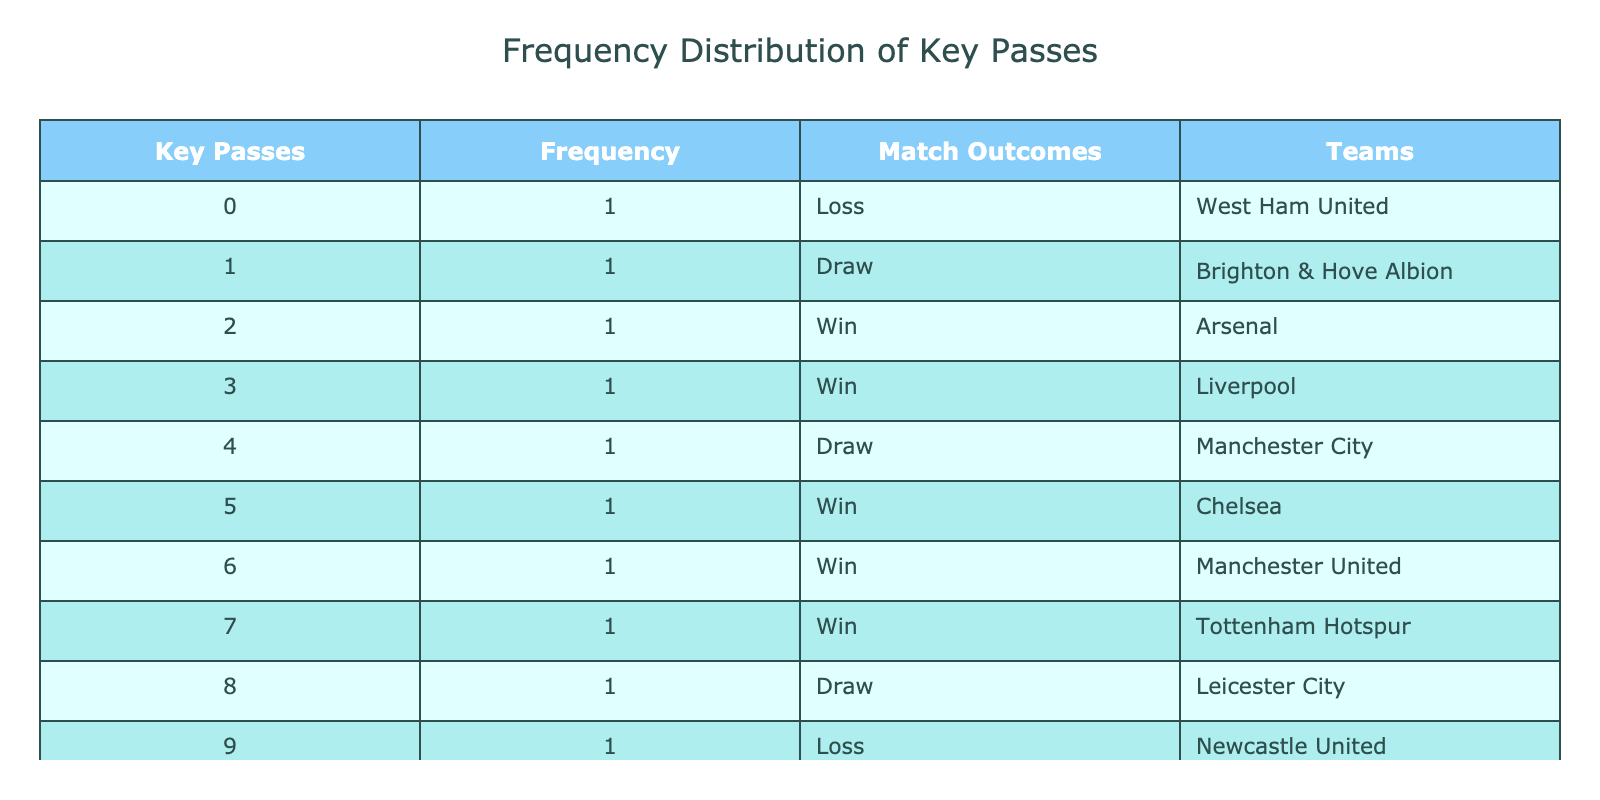What is the total number of matches that resulted in a win? To find the total number of wins, we need to count the matches in the "Match Outcomes" column that are labeled as "Win." There are five outcomes marked as "Win" (Arsenal, Liverpool, Chelsea, Manchester United, Tottenham Hotspur, and Everton).
Answer: 6 Which team had the highest number of key passes in a single match? To identify the team with the highest number of key passes, we look at the "Key Passes" column and find the maximum value, which is 10. The team corresponding to this value is Everton.
Answer: Everton Did any matches with 0 key passes result in a win? Looking at the row with 0 key passes, the match outcome is "Loss" for West Ham United. Therefore, no matches with 0 key passes resulted in a win.
Answer: No How many teams drew matches that had exactly 1 key pass? To answer this, we check the "Key Passes" column for the value 1 and find that it corresponds to one match, which ended in a "Draw," for Brighton & Hove Albion. Thus, there is only one team that drew matches with exactly 1 key pass.
Answer: 1 What is the difference in the number of matches won compared to those that ended in a draw? Using the counts of outcomes, there are 6 matches that resulted in a win (total of 6) and 4 matches that ended in a draw (Brighton & Hove Albion, Manchester City, Leicester City). The difference is calculated as follows: 6 (wins) - 3 (draws) = 3.
Answer: 3 Are there any teams that lost matches while making more than 3 key passes? Checking the "Match Outcomes" for teams with greater than 3 key passes shows that Newcastle United, who lost, only made 9 key passes. Therefore, there is indeed a team that lost while achieving 9 key passes.
Answer: Yes What is the frequency of matches that resulted in a loss? To find the frequency of losses, we should count how many rows indicate a "Loss" in the "Match Outcome" column. There are two matches labeled as "Loss" (West Ham United, Newcastle United).
Answer: 2 How many teams had a match outcome classified as "Draw" while also making an even number of key passes? From the table, we see that teams with an even number of key passes that resulted in a draw include Manchester City (4 key passes) and Leicester City (8 key passes), totalling two teams.
Answer: 2 